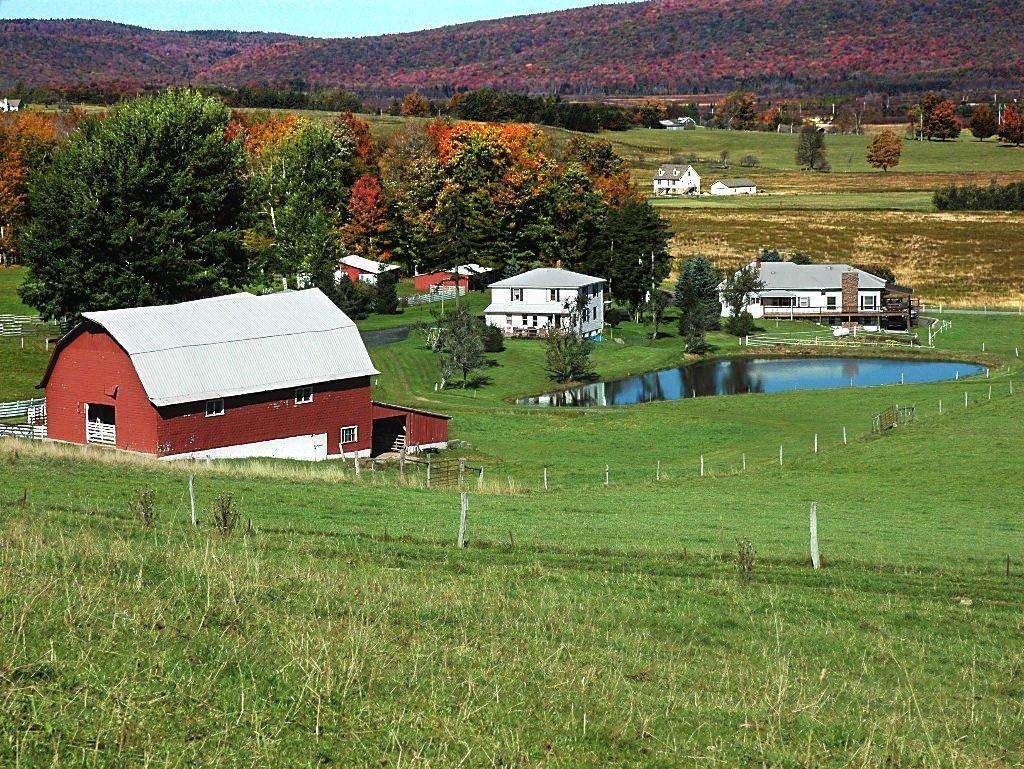Please provide a concise description of this image. In this image I can see houses and a pole and in the middle and I can see trees at the top I can see the sky and the hill ,at bottom I can see grass. 